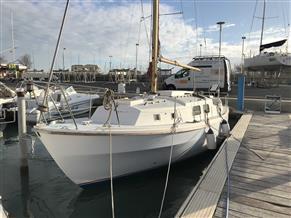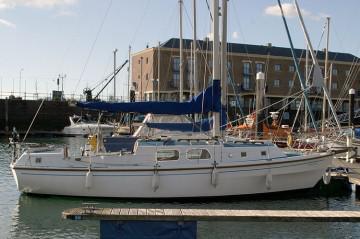The first image is the image on the left, the second image is the image on the right. For the images shown, is this caption "All of the sailboats pictured a currently moored or a at a dock." true? Answer yes or no. Yes. The first image is the image on the left, the second image is the image on the right. Evaluate the accuracy of this statement regarding the images: "There are at least two blue sails.". Is it true? Answer yes or no. Yes. 